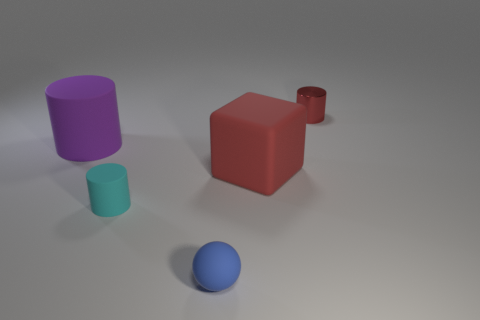Add 1 yellow things. How many objects exist? 6 Subtract all blocks. How many objects are left? 4 Add 1 purple matte things. How many purple matte things are left? 2 Add 4 cylinders. How many cylinders exist? 7 Subtract 1 cyan cylinders. How many objects are left? 4 Subtract all small cylinders. Subtract all rubber cylinders. How many objects are left? 1 